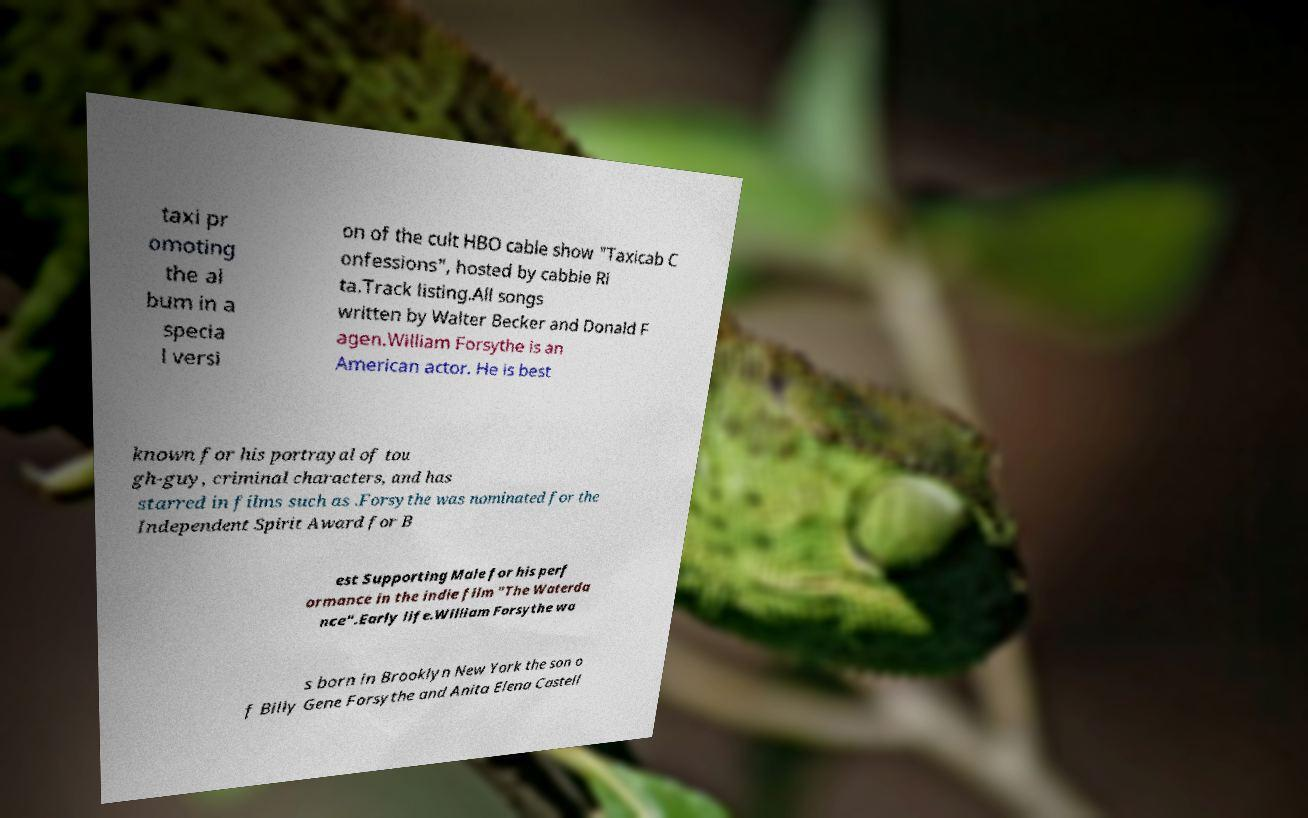What messages or text are displayed in this image? I need them in a readable, typed format. taxi pr omoting the al bum in a specia l versi on of the cult HBO cable show "Taxicab C onfessions", hosted by cabbie Ri ta.Track listing.All songs written by Walter Becker and Donald F agen.William Forsythe is an American actor. He is best known for his portrayal of tou gh-guy, criminal characters, and has starred in films such as .Forsythe was nominated for the Independent Spirit Award for B est Supporting Male for his perf ormance in the indie film "The Waterda nce".Early life.William Forsythe wa s born in Brooklyn New York the son o f Billy Gene Forsythe and Anita Elena Castell 